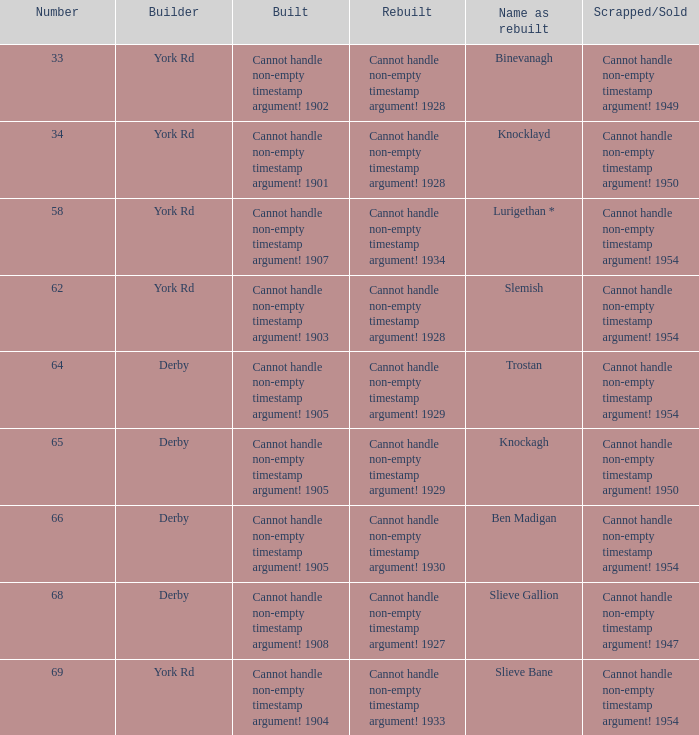Which reconstruction is named as the reconstruction of binevanagh? Cannot handle non-empty timestamp argument! 1928. 